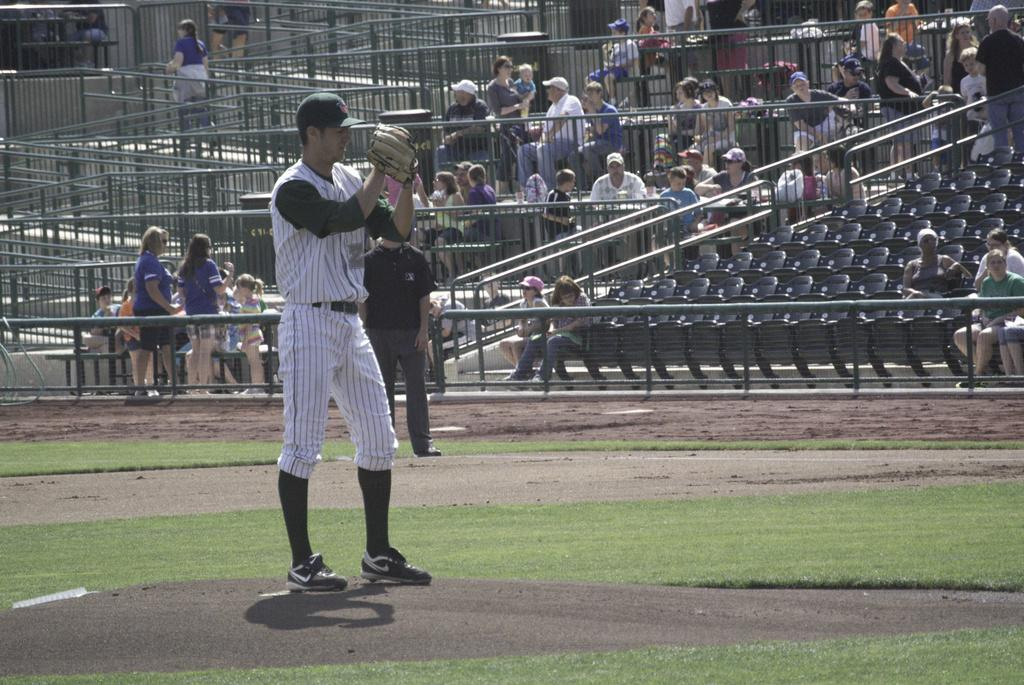How many people are playing baseball in the image? There are two men in the image who are playing baseball. What are the men doing in the image? The men are playing baseball. Can you describe the scene in the background of the image? There are spectators in the background of the image who are watching the baseball match. What type of appliance can be seen in the image? There is no appliance present in the image; it features two men playing baseball and spectators watching the match. 